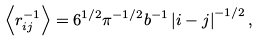Convert formula to latex. <formula><loc_0><loc_0><loc_500><loc_500>\left < r _ { i j } ^ { - 1 } \right > = 6 ^ { 1 / 2 } \pi ^ { - 1 / 2 } b ^ { - 1 } \left | i - j \right | ^ { - 1 / 2 } ,</formula> 